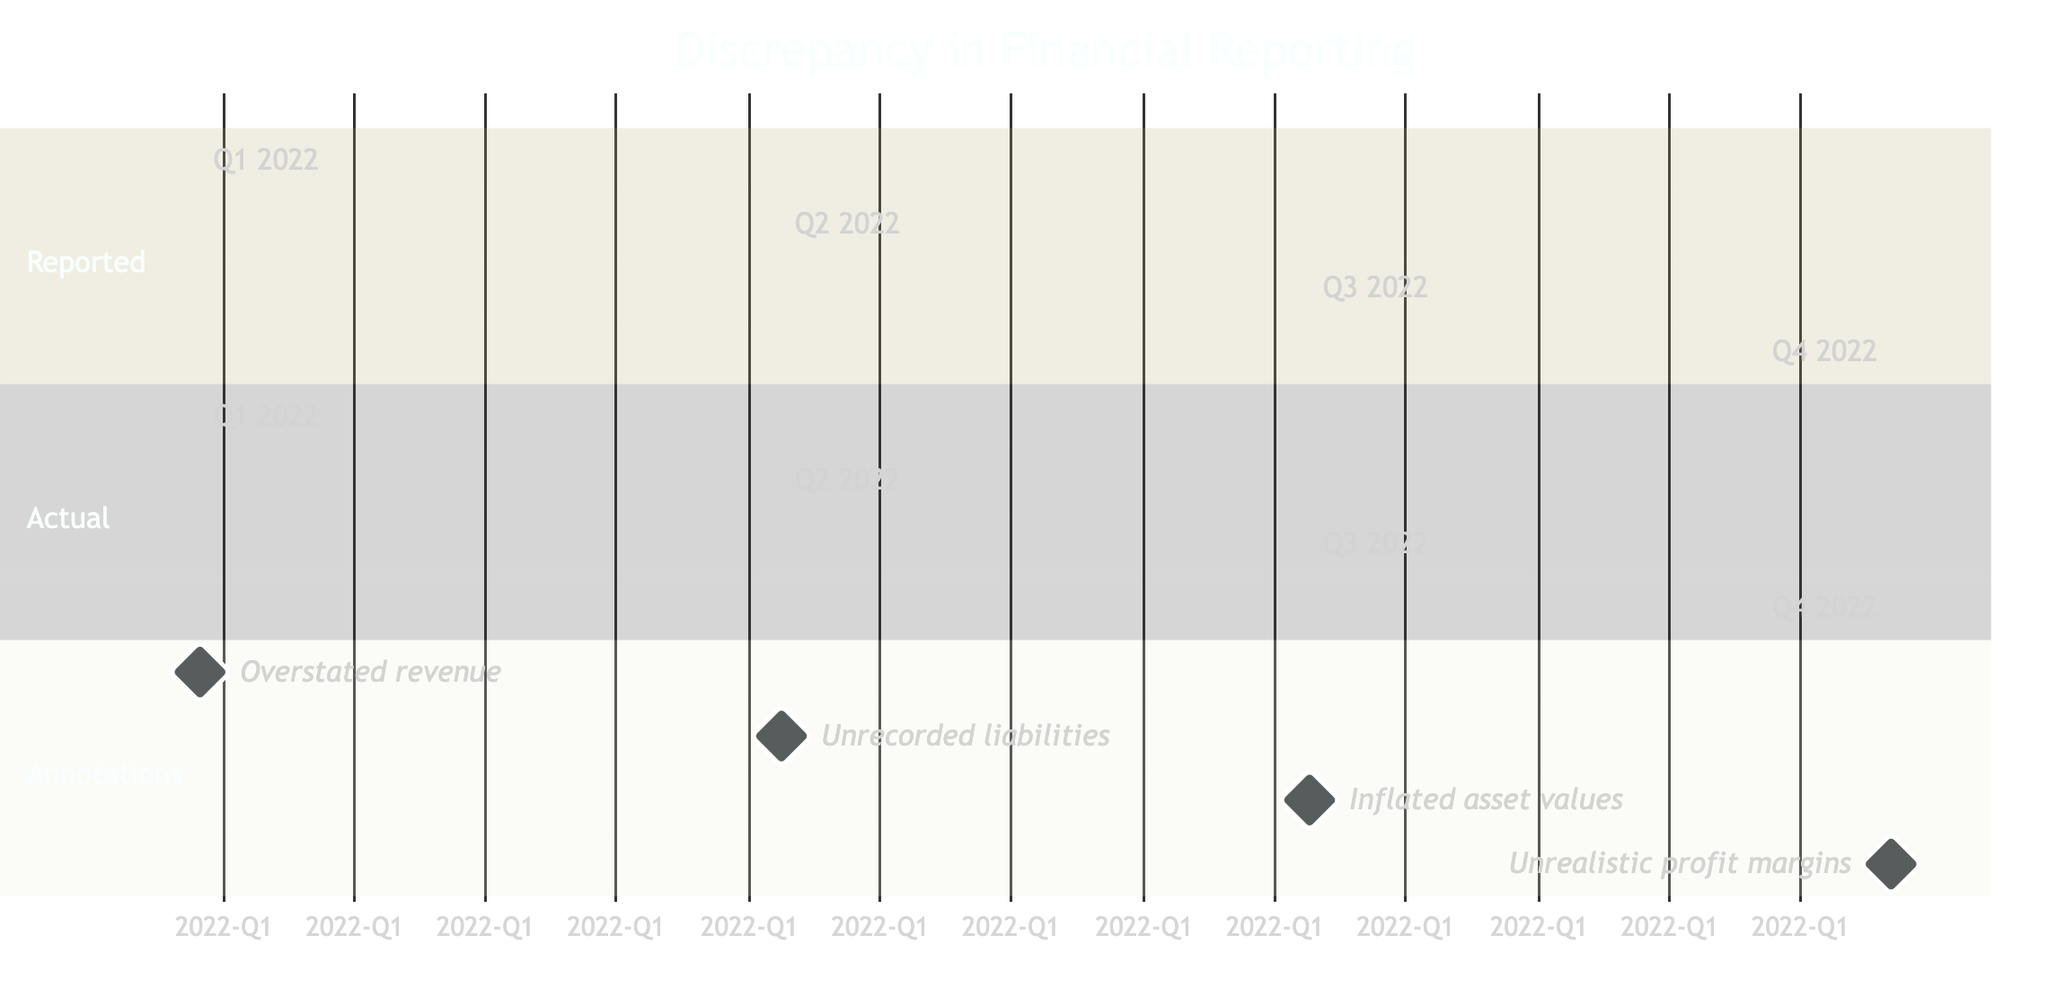What is the reported revenue for Q4 2022? The diagram indicates that the reported revenue for Q4 2022 is listed under the 'Reported' section as 260.
Answer: 260 What is the actual revenue for Q1 2022? The diagram shows that the actual revenue for Q1 2022 is specified in the 'Actual' section as 170.
Answer: 170 How many quarters are represented in the diagram? There are four quarters represented in the diagram, as indicated by the data shown for Q1 through Q4 of 2022.
Answer: 4 What is the discrepancy between the reported and actual figures for Q3 2022? For Q3 2022, the reported revenue is 240, and the actual revenue is 200. The discrepancy is 240 - 200 = 40.
Answer: 40 Which quarter has the highest reported revenue? Looking through the 'Reported' section, Q4 2022 has the highest reported revenue at 260.
Answer: Q4 2022 What potential source of irregularity is indicated for Q1 2022? The diagram indicates "Overstated revenue" as the potential source of irregularity marked in the 'Annotations' section for Q1 2022.
Answer: Overstated revenue In which quarter was unrecorded liabilities noted? According to the 'Annotations' section, unrecorded liabilities were noted for Q2 2022.
Answer: Q2 2022 What is the difference between the reported and actual revenue in Q4 2022? The reported revenue for Q4 2022 is 260, while the actual is 210, making the difference 260 - 210 = 50.
Answer: 50 Which annotation corresponds to Q3 2022? The annotation for Q3 2022 is "Inflated asset values," as noted in the 'Annotations' section.
Answer: Inflated asset values 